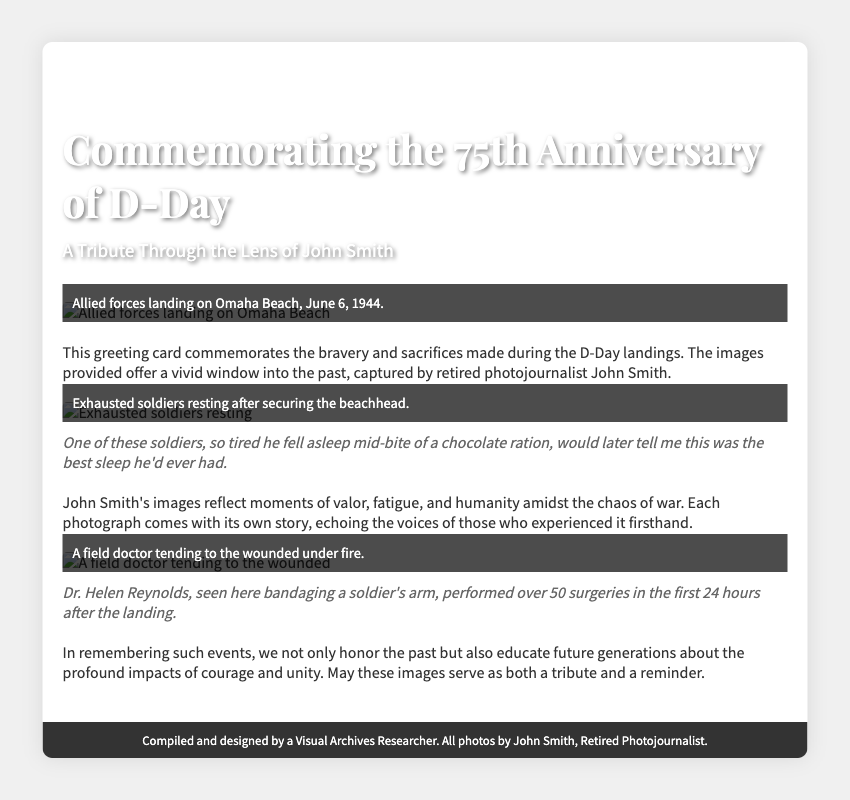What is the title of the card? The title is prominently displayed at the top of the document.
Answer: Commemorating the 75th Anniversary of D-Day Who is the retired photojournalist featured in this card? The card mentions the name of the featured photojournalist in the subtitle.
Answer: John Smith What year did the D-Day landings occur? The document provides a specific date related to the historical event being commemorated.
Answer: 1944 How many surgeries did Dr. Helen Reynolds perform in the first 24 hours after the landing? This information is found in the anecdote about Dr. Helen Reynolds.
Answer: Over 50 What is the main purpose of this greeting card? The document describes why the card was created in one of the text sections.
Answer: To commemorate bravery and sacrifices What scene is depicted in the first image? The caption under the first image describes the scene clearly.
Answer: Allied forces landing on Omaha Beach What emotion do John Smith's images aim to convey? The text mentions the focus of the images on human elements amid chaos.
Answer: Valor, fatigue, and humanity How does the card suggest we honor the past? The document provides a philosophical reflection on the importance of remembering such events.
Answer: Educate future generations 